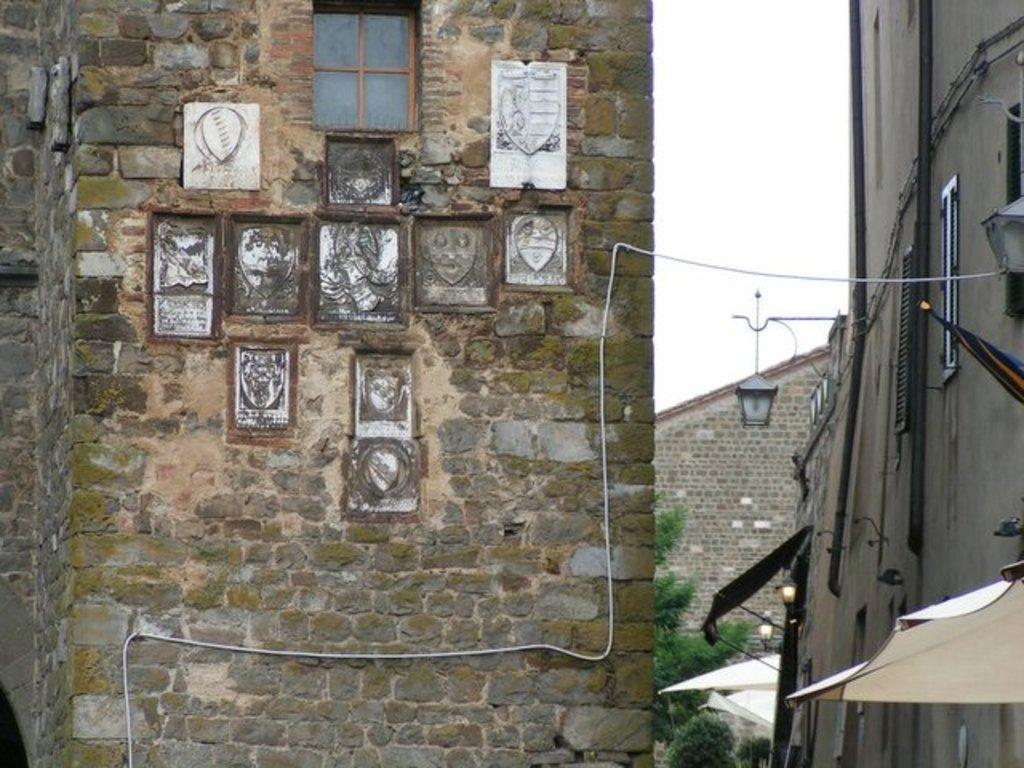What can be seen on the wall in the image? There are boards on the wall in the image. What type of structures are visible in the image? There are buildings with windows in the image. What type of lighting is present in the image? Lamps are present in the image. What type of shade is visible in the image? Sunshades are visible in the image. What type of vegetation is present in the image? Trees are present in the image. What other unspecified objects can be seen in the image? There are some unspecified objects in the image. What can be seen in the background of the image? The sky is visible in the background of the image. How many dinosaurs are visible in the image? There are no dinosaurs present in the image. What type of pipe is visible in the image? There is no pipe present in the image. 